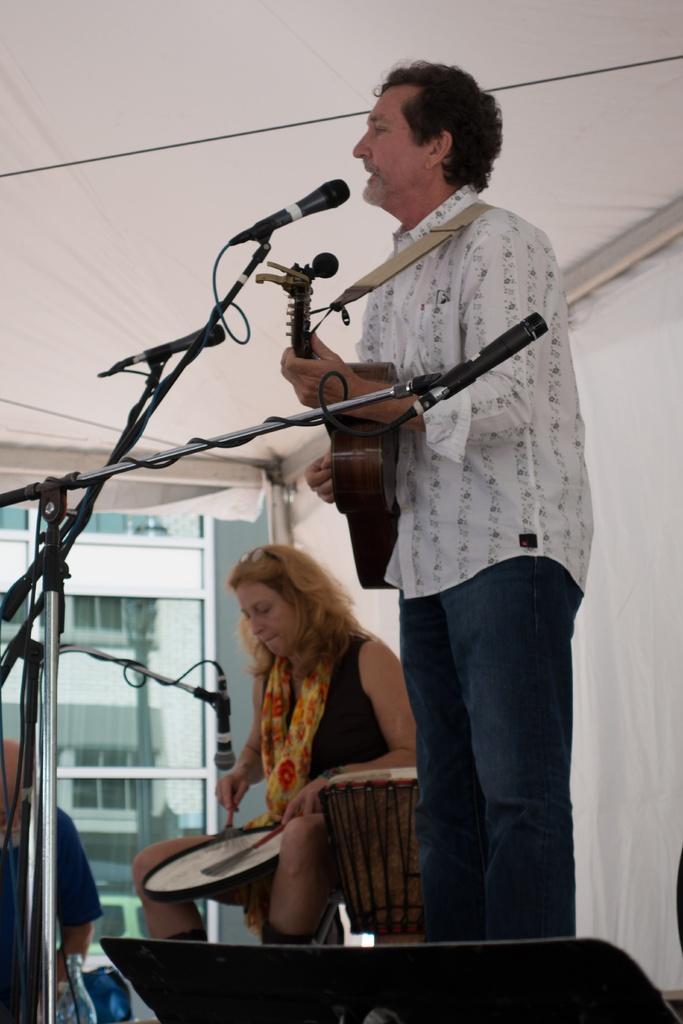Please provide a concise description of this image. In this image there is a person wearing white color shirt playing guitar in front of him there is a microphone and at the background of the image there is a woman beating drums. 